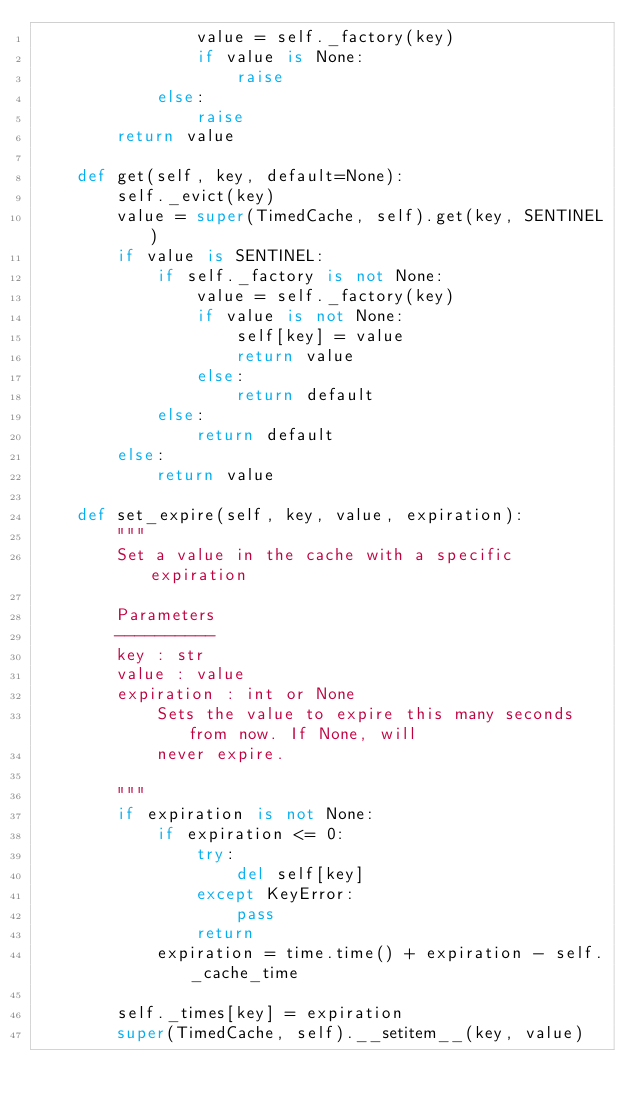Convert code to text. <code><loc_0><loc_0><loc_500><loc_500><_Python_>                value = self._factory(key)
                if value is None:
                    raise
            else:
                raise
        return value

    def get(self, key, default=None):
        self._evict(key)
        value = super(TimedCache, self).get(key, SENTINEL)
        if value is SENTINEL:
            if self._factory is not None:
                value = self._factory(key)
                if value is not None:
                    self[key] = value
                    return value
                else:
                    return default
            else:
                return default
        else:
            return value

    def set_expire(self, key, value, expiration):
        """
        Set a value in the cache with a specific expiration

        Parameters
        ----------
        key : str
        value : value
        expiration : int or None
            Sets the value to expire this many seconds from now. If None, will
            never expire.

        """
        if expiration is not None:
            if expiration <= 0:
                try:
                    del self[key]
                except KeyError:
                    pass
                return
            expiration = time.time() + expiration - self._cache_time

        self._times[key] = expiration
        super(TimedCache, self).__setitem__(key, value)
</code> 